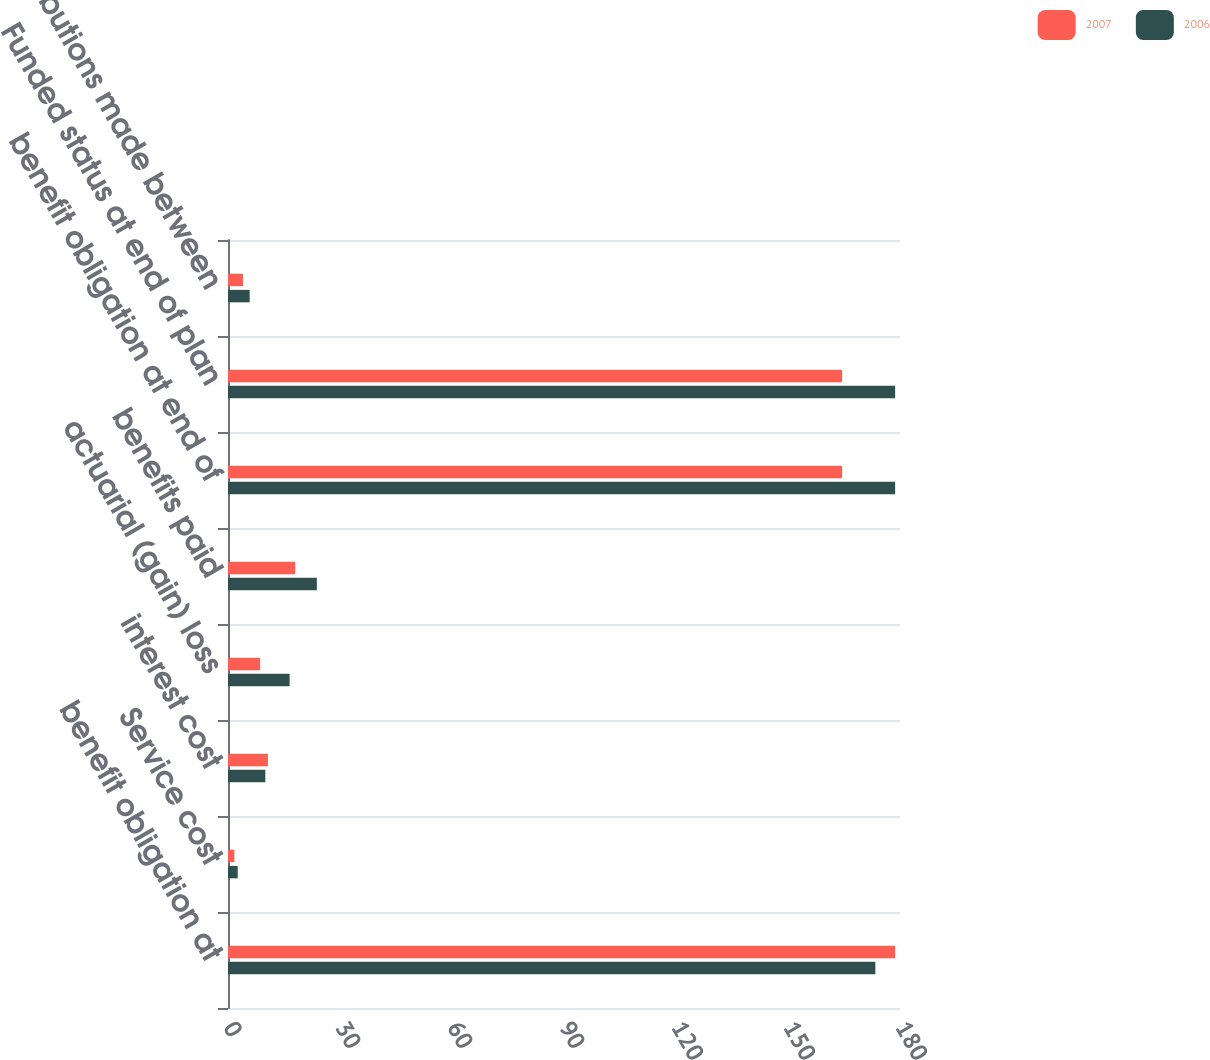Convert chart. <chart><loc_0><loc_0><loc_500><loc_500><stacked_bar_chart><ecel><fcel>benefit obligation at<fcel>Service cost<fcel>interest cost<fcel>actuarial (gain) loss<fcel>benefits paid<fcel>benefit obligation at end of<fcel>Funded status at end of plan<fcel>contributions made between<nl><fcel>2007<fcel>178.7<fcel>1.7<fcel>10.7<fcel>8.6<fcel>18<fcel>164.5<fcel>164.5<fcel>4<nl><fcel>2006<fcel>173.4<fcel>2.6<fcel>10<fcel>16.5<fcel>23.8<fcel>178.7<fcel>178.7<fcel>5.8<nl></chart> 